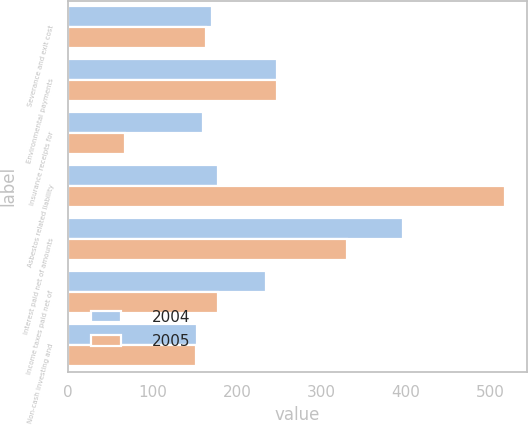Convert chart to OTSL. <chart><loc_0><loc_0><loc_500><loc_500><stacked_bar_chart><ecel><fcel>Severance and exit cost<fcel>Environmental payments<fcel>Insurance receipts for<fcel>Asbestos related liability<fcel>Interest paid net of amounts<fcel>Income taxes paid net of<fcel>Non-cash investing and<nl><fcel>2004<fcel>171<fcel>247<fcel>160<fcel>178<fcel>397<fcel>235<fcel>153<nl><fcel>2005<fcel>164<fcel>248<fcel>67<fcel>518<fcel>330<fcel>178<fcel>151<nl></chart> 